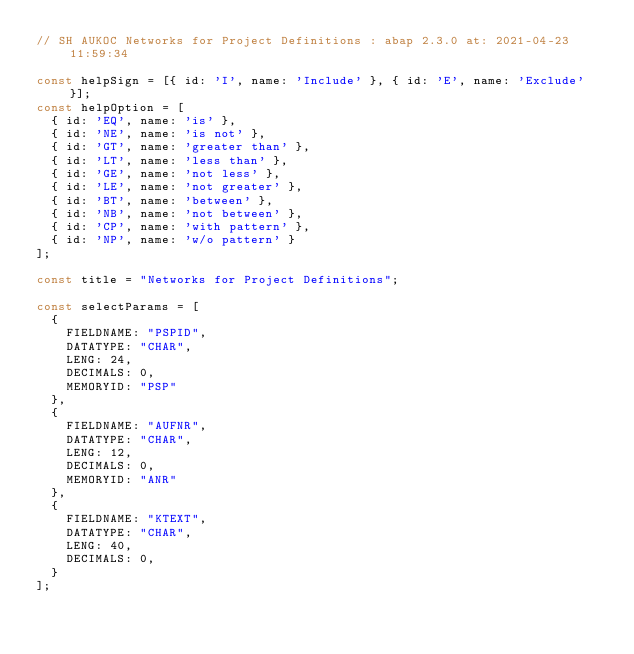<code> <loc_0><loc_0><loc_500><loc_500><_JavaScript_>// SH AUKOC Networks for Project Definitions : abap 2.3.0 at: 2021-04-23 11:59:34

const helpSign = [{ id: 'I', name: 'Include' }, { id: 'E', name: 'Exclude' }];
const helpOption = [
  { id: 'EQ', name: 'is' },
  { id: 'NE', name: 'is not' },
  { id: 'GT', name: 'greater than' },
  { id: 'LT', name: 'less than' },
  { id: 'GE', name: 'not less' },
  { id: 'LE', name: 'not greater' },
  { id: 'BT', name: 'between' },
  { id: 'NB', name: 'not between' },
  { id: 'CP', name: 'with pattern' },
  { id: 'NP', name: 'w/o pattern' }
];

const title = "Networks for Project Definitions";

const selectParams = [
  {
    FIELDNAME: "PSPID",
    DATATYPE: "CHAR",
    LENG: 24,
    DECIMALS: 0,
    MEMORYID: "PSP"
  },
  {
    FIELDNAME: "AUFNR",
    DATATYPE: "CHAR",
    LENG: 12,
    DECIMALS: 0,
    MEMORYID: "ANR"
  },
  {
    FIELDNAME: "KTEXT",
    DATATYPE: "CHAR",
    LENG: 40,
    DECIMALS: 0,
  }
];</code> 